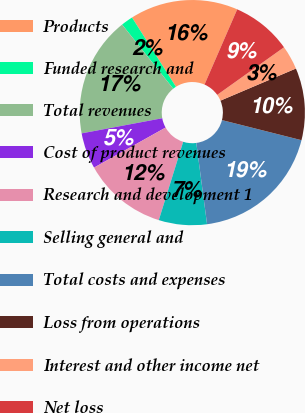Convert chart to OTSL. <chart><loc_0><loc_0><loc_500><loc_500><pie_chart><fcel>Products<fcel>Funded research and<fcel>Total revenues<fcel>Cost of product revenues<fcel>Research and development 1<fcel>Selling general and<fcel>Total costs and expenses<fcel>Loss from operations<fcel>Interest and other income net<fcel>Net loss<nl><fcel>15.52%<fcel>1.72%<fcel>17.24%<fcel>5.17%<fcel>12.07%<fcel>6.9%<fcel>18.97%<fcel>10.34%<fcel>3.45%<fcel>8.62%<nl></chart> 